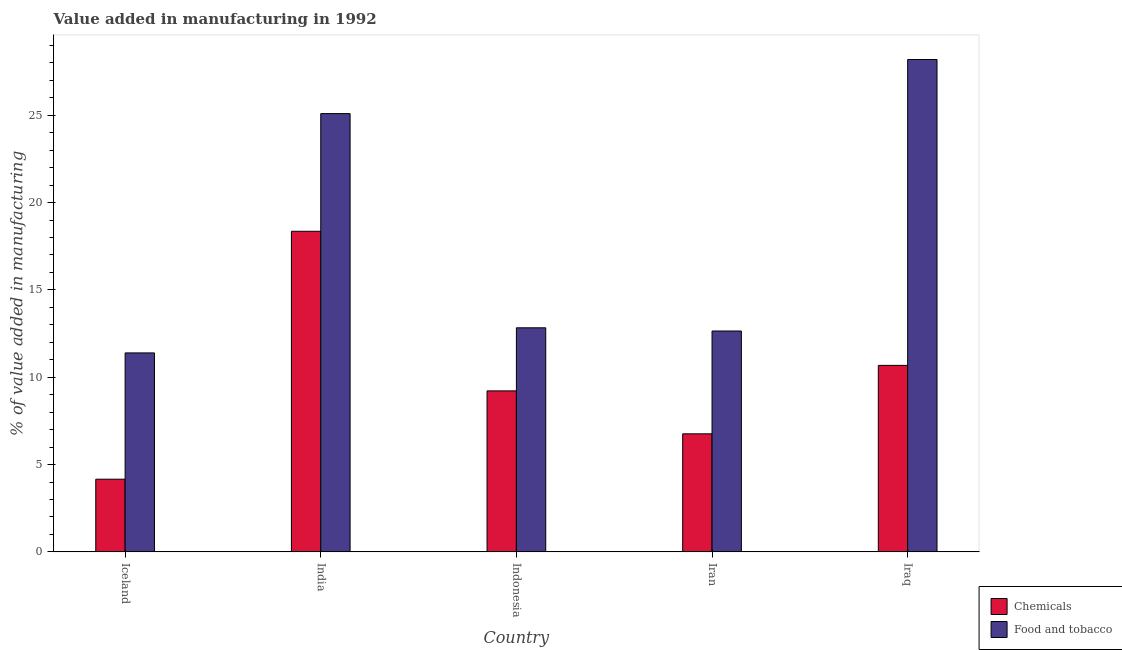How many different coloured bars are there?
Your answer should be compact. 2. Are the number of bars on each tick of the X-axis equal?
Give a very brief answer. Yes. What is the label of the 3rd group of bars from the left?
Provide a succinct answer. Indonesia. In how many cases, is the number of bars for a given country not equal to the number of legend labels?
Give a very brief answer. 0. What is the value added by  manufacturing chemicals in Iceland?
Provide a short and direct response. 4.16. Across all countries, what is the maximum value added by  manufacturing chemicals?
Ensure brevity in your answer.  18.36. Across all countries, what is the minimum value added by manufacturing food and tobacco?
Offer a terse response. 11.39. In which country was the value added by manufacturing food and tobacco maximum?
Your answer should be very brief. Iraq. What is the total value added by  manufacturing chemicals in the graph?
Offer a very short reply. 49.17. What is the difference between the value added by manufacturing food and tobacco in India and that in Indonesia?
Your answer should be compact. 12.26. What is the difference between the value added by  manufacturing chemicals in Iran and the value added by manufacturing food and tobacco in Iraq?
Ensure brevity in your answer.  -21.43. What is the average value added by manufacturing food and tobacco per country?
Your response must be concise. 18.03. What is the difference between the value added by manufacturing food and tobacco and value added by  manufacturing chemicals in Iraq?
Give a very brief answer. 17.51. In how many countries, is the value added by  manufacturing chemicals greater than 9 %?
Ensure brevity in your answer.  3. What is the ratio of the value added by  manufacturing chemicals in Indonesia to that in Iraq?
Offer a terse response. 0.86. What is the difference between the highest and the second highest value added by manufacturing food and tobacco?
Your answer should be very brief. 3.1. What is the difference between the highest and the lowest value added by  manufacturing chemicals?
Offer a very short reply. 14.2. In how many countries, is the value added by manufacturing food and tobacco greater than the average value added by manufacturing food and tobacco taken over all countries?
Make the answer very short. 2. Is the sum of the value added by manufacturing food and tobacco in Indonesia and Iran greater than the maximum value added by  manufacturing chemicals across all countries?
Make the answer very short. Yes. What does the 2nd bar from the left in Iceland represents?
Offer a terse response. Food and tobacco. What does the 2nd bar from the right in Iran represents?
Offer a terse response. Chemicals. How many bars are there?
Give a very brief answer. 10. Are all the bars in the graph horizontal?
Make the answer very short. No. How many countries are there in the graph?
Your response must be concise. 5. Does the graph contain any zero values?
Give a very brief answer. No. How many legend labels are there?
Offer a very short reply. 2. What is the title of the graph?
Give a very brief answer. Value added in manufacturing in 1992. What is the label or title of the X-axis?
Provide a short and direct response. Country. What is the label or title of the Y-axis?
Offer a very short reply. % of value added in manufacturing. What is the % of value added in manufacturing in Chemicals in Iceland?
Your answer should be very brief. 4.16. What is the % of value added in manufacturing of Food and tobacco in Iceland?
Offer a very short reply. 11.39. What is the % of value added in manufacturing of Chemicals in India?
Make the answer very short. 18.36. What is the % of value added in manufacturing of Food and tobacco in India?
Your answer should be compact. 25.09. What is the % of value added in manufacturing in Chemicals in Indonesia?
Keep it short and to the point. 9.22. What is the % of value added in manufacturing in Food and tobacco in Indonesia?
Keep it short and to the point. 12.83. What is the % of value added in manufacturing of Chemicals in Iran?
Your answer should be compact. 6.76. What is the % of value added in manufacturing of Food and tobacco in Iran?
Provide a succinct answer. 12.65. What is the % of value added in manufacturing of Chemicals in Iraq?
Keep it short and to the point. 10.68. What is the % of value added in manufacturing in Food and tobacco in Iraq?
Ensure brevity in your answer.  28.19. Across all countries, what is the maximum % of value added in manufacturing of Chemicals?
Ensure brevity in your answer.  18.36. Across all countries, what is the maximum % of value added in manufacturing in Food and tobacco?
Your answer should be compact. 28.19. Across all countries, what is the minimum % of value added in manufacturing of Chemicals?
Provide a short and direct response. 4.16. Across all countries, what is the minimum % of value added in manufacturing in Food and tobacco?
Provide a short and direct response. 11.39. What is the total % of value added in manufacturing in Chemicals in the graph?
Ensure brevity in your answer.  49.17. What is the total % of value added in manufacturing in Food and tobacco in the graph?
Keep it short and to the point. 90.16. What is the difference between the % of value added in manufacturing of Chemicals in Iceland and that in India?
Keep it short and to the point. -14.2. What is the difference between the % of value added in manufacturing of Food and tobacco in Iceland and that in India?
Give a very brief answer. -13.7. What is the difference between the % of value added in manufacturing in Chemicals in Iceland and that in Indonesia?
Give a very brief answer. -5.06. What is the difference between the % of value added in manufacturing in Food and tobacco in Iceland and that in Indonesia?
Give a very brief answer. -1.44. What is the difference between the % of value added in manufacturing of Chemicals in Iceland and that in Iran?
Make the answer very short. -2.6. What is the difference between the % of value added in manufacturing of Food and tobacco in Iceland and that in Iran?
Offer a terse response. -1.25. What is the difference between the % of value added in manufacturing of Chemicals in Iceland and that in Iraq?
Offer a very short reply. -6.52. What is the difference between the % of value added in manufacturing in Food and tobacco in Iceland and that in Iraq?
Give a very brief answer. -16.8. What is the difference between the % of value added in manufacturing in Chemicals in India and that in Indonesia?
Ensure brevity in your answer.  9.14. What is the difference between the % of value added in manufacturing of Food and tobacco in India and that in Indonesia?
Keep it short and to the point. 12.26. What is the difference between the % of value added in manufacturing in Chemicals in India and that in Iran?
Ensure brevity in your answer.  11.6. What is the difference between the % of value added in manufacturing in Food and tobacco in India and that in Iran?
Provide a succinct answer. 12.45. What is the difference between the % of value added in manufacturing of Chemicals in India and that in Iraq?
Provide a succinct answer. 7.68. What is the difference between the % of value added in manufacturing in Food and tobacco in India and that in Iraq?
Offer a very short reply. -3.1. What is the difference between the % of value added in manufacturing in Chemicals in Indonesia and that in Iran?
Give a very brief answer. 2.46. What is the difference between the % of value added in manufacturing in Food and tobacco in Indonesia and that in Iran?
Provide a short and direct response. 0.18. What is the difference between the % of value added in manufacturing of Chemicals in Indonesia and that in Iraq?
Keep it short and to the point. -1.46. What is the difference between the % of value added in manufacturing of Food and tobacco in Indonesia and that in Iraq?
Provide a short and direct response. -15.36. What is the difference between the % of value added in manufacturing of Chemicals in Iran and that in Iraq?
Offer a terse response. -3.92. What is the difference between the % of value added in manufacturing of Food and tobacco in Iran and that in Iraq?
Provide a short and direct response. -15.55. What is the difference between the % of value added in manufacturing of Chemicals in Iceland and the % of value added in manufacturing of Food and tobacco in India?
Your response must be concise. -20.93. What is the difference between the % of value added in manufacturing in Chemicals in Iceland and the % of value added in manufacturing in Food and tobacco in Indonesia?
Your answer should be very brief. -8.67. What is the difference between the % of value added in manufacturing in Chemicals in Iceland and the % of value added in manufacturing in Food and tobacco in Iran?
Give a very brief answer. -8.49. What is the difference between the % of value added in manufacturing of Chemicals in Iceland and the % of value added in manufacturing of Food and tobacco in Iraq?
Your response must be concise. -24.03. What is the difference between the % of value added in manufacturing of Chemicals in India and the % of value added in manufacturing of Food and tobacco in Indonesia?
Your answer should be compact. 5.53. What is the difference between the % of value added in manufacturing in Chemicals in India and the % of value added in manufacturing in Food and tobacco in Iran?
Offer a very short reply. 5.71. What is the difference between the % of value added in manufacturing of Chemicals in India and the % of value added in manufacturing of Food and tobacco in Iraq?
Your answer should be compact. -9.84. What is the difference between the % of value added in manufacturing in Chemicals in Indonesia and the % of value added in manufacturing in Food and tobacco in Iran?
Your answer should be very brief. -3.43. What is the difference between the % of value added in manufacturing in Chemicals in Indonesia and the % of value added in manufacturing in Food and tobacco in Iraq?
Give a very brief answer. -18.97. What is the difference between the % of value added in manufacturing in Chemicals in Iran and the % of value added in manufacturing in Food and tobacco in Iraq?
Make the answer very short. -21.43. What is the average % of value added in manufacturing in Chemicals per country?
Your response must be concise. 9.83. What is the average % of value added in manufacturing of Food and tobacco per country?
Your response must be concise. 18.03. What is the difference between the % of value added in manufacturing in Chemicals and % of value added in manufacturing in Food and tobacco in Iceland?
Keep it short and to the point. -7.23. What is the difference between the % of value added in manufacturing in Chemicals and % of value added in manufacturing in Food and tobacco in India?
Offer a terse response. -6.74. What is the difference between the % of value added in manufacturing of Chemicals and % of value added in manufacturing of Food and tobacco in Indonesia?
Provide a succinct answer. -3.61. What is the difference between the % of value added in manufacturing in Chemicals and % of value added in manufacturing in Food and tobacco in Iran?
Give a very brief answer. -5.89. What is the difference between the % of value added in manufacturing of Chemicals and % of value added in manufacturing of Food and tobacco in Iraq?
Your answer should be very brief. -17.51. What is the ratio of the % of value added in manufacturing of Chemicals in Iceland to that in India?
Offer a terse response. 0.23. What is the ratio of the % of value added in manufacturing of Food and tobacco in Iceland to that in India?
Make the answer very short. 0.45. What is the ratio of the % of value added in manufacturing of Chemicals in Iceland to that in Indonesia?
Provide a succinct answer. 0.45. What is the ratio of the % of value added in manufacturing of Food and tobacco in Iceland to that in Indonesia?
Your answer should be compact. 0.89. What is the ratio of the % of value added in manufacturing in Chemicals in Iceland to that in Iran?
Make the answer very short. 0.62. What is the ratio of the % of value added in manufacturing in Food and tobacco in Iceland to that in Iran?
Ensure brevity in your answer.  0.9. What is the ratio of the % of value added in manufacturing of Chemicals in Iceland to that in Iraq?
Ensure brevity in your answer.  0.39. What is the ratio of the % of value added in manufacturing of Food and tobacco in Iceland to that in Iraq?
Give a very brief answer. 0.4. What is the ratio of the % of value added in manufacturing of Chemicals in India to that in Indonesia?
Offer a terse response. 1.99. What is the ratio of the % of value added in manufacturing in Food and tobacco in India to that in Indonesia?
Your response must be concise. 1.96. What is the ratio of the % of value added in manufacturing of Chemicals in India to that in Iran?
Make the answer very short. 2.72. What is the ratio of the % of value added in manufacturing of Food and tobacco in India to that in Iran?
Ensure brevity in your answer.  1.98. What is the ratio of the % of value added in manufacturing of Chemicals in India to that in Iraq?
Keep it short and to the point. 1.72. What is the ratio of the % of value added in manufacturing in Food and tobacco in India to that in Iraq?
Offer a terse response. 0.89. What is the ratio of the % of value added in manufacturing of Chemicals in Indonesia to that in Iran?
Provide a short and direct response. 1.36. What is the ratio of the % of value added in manufacturing of Food and tobacco in Indonesia to that in Iran?
Your answer should be compact. 1.01. What is the ratio of the % of value added in manufacturing of Chemicals in Indonesia to that in Iraq?
Your answer should be very brief. 0.86. What is the ratio of the % of value added in manufacturing in Food and tobacco in Indonesia to that in Iraq?
Ensure brevity in your answer.  0.46. What is the ratio of the % of value added in manufacturing of Chemicals in Iran to that in Iraq?
Provide a succinct answer. 0.63. What is the ratio of the % of value added in manufacturing in Food and tobacco in Iran to that in Iraq?
Your answer should be compact. 0.45. What is the difference between the highest and the second highest % of value added in manufacturing of Chemicals?
Give a very brief answer. 7.68. What is the difference between the highest and the second highest % of value added in manufacturing in Food and tobacco?
Give a very brief answer. 3.1. What is the difference between the highest and the lowest % of value added in manufacturing in Chemicals?
Offer a terse response. 14.2. What is the difference between the highest and the lowest % of value added in manufacturing of Food and tobacco?
Offer a very short reply. 16.8. 